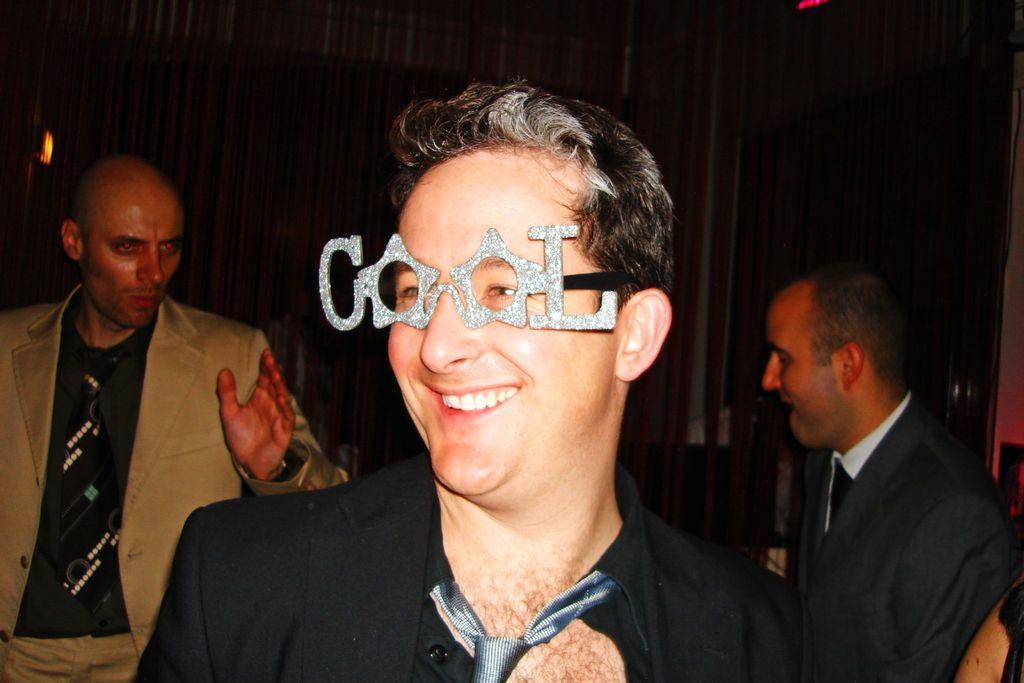Could you give a brief overview of what you see in this image? In front of the image there is a person with a smile on his face is wearing a decorative eyewear, behind him there are two other people, behind them there is a wall. 